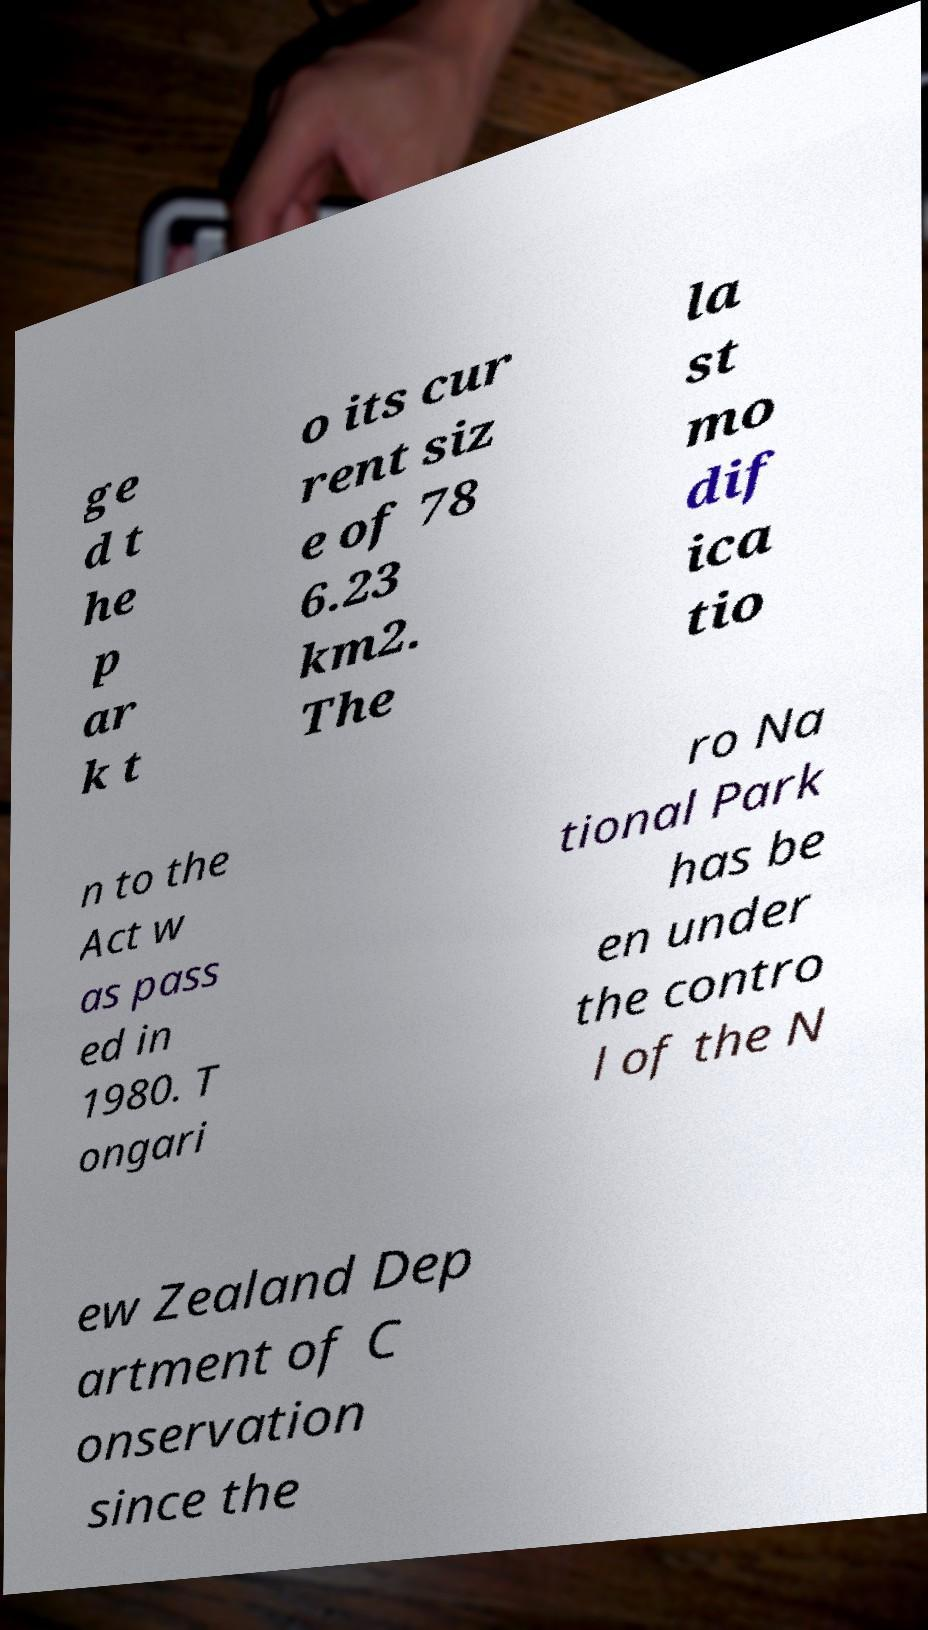Please read and relay the text visible in this image. What does it say? ge d t he p ar k t o its cur rent siz e of 78 6.23 km2. The la st mo dif ica tio n to the Act w as pass ed in 1980. T ongari ro Na tional Park has be en under the contro l of the N ew Zealand Dep artment of C onservation since the 